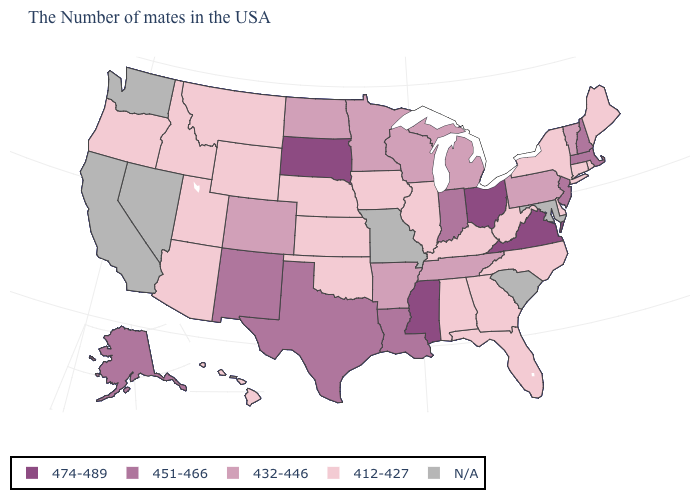Does Connecticut have the lowest value in the USA?
Answer briefly. Yes. Is the legend a continuous bar?
Write a very short answer. No. What is the value of Pennsylvania?
Concise answer only. 432-446. Name the states that have a value in the range 474-489?
Quick response, please. Virginia, Ohio, Mississippi, South Dakota. Does Nebraska have the lowest value in the USA?
Short answer required. Yes. Name the states that have a value in the range 474-489?
Quick response, please. Virginia, Ohio, Mississippi, South Dakota. Does Nebraska have the lowest value in the MidWest?
Quick response, please. Yes. What is the lowest value in the USA?
Write a very short answer. 412-427. What is the highest value in the West ?
Write a very short answer. 451-466. Is the legend a continuous bar?
Quick response, please. No. Among the states that border Michigan , which have the highest value?
Be succinct. Ohio. Does Rhode Island have the highest value in the Northeast?
Keep it brief. No. Name the states that have a value in the range 432-446?
Give a very brief answer. Vermont, Pennsylvania, Michigan, Tennessee, Wisconsin, Arkansas, Minnesota, North Dakota, Colorado. What is the value of Mississippi?
Keep it brief. 474-489. Does the map have missing data?
Short answer required. Yes. 